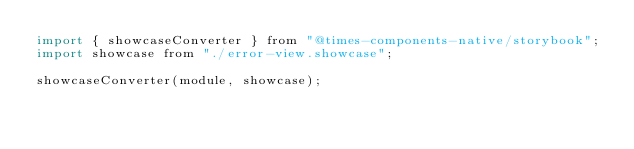<code> <loc_0><loc_0><loc_500><loc_500><_JavaScript_>import { showcaseConverter } from "@times-components-native/storybook";
import showcase from "./error-view.showcase";

showcaseConverter(module, showcase);
</code> 